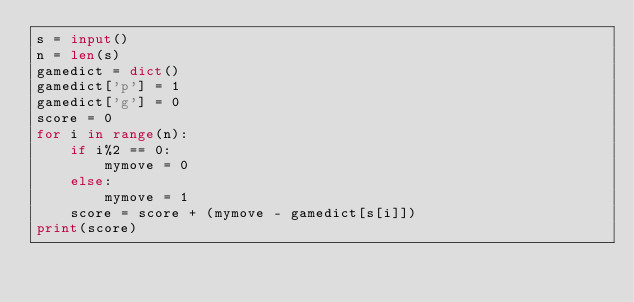Convert code to text. <code><loc_0><loc_0><loc_500><loc_500><_Python_>s = input()
n = len(s)
gamedict = dict()
gamedict['p'] = 1
gamedict['g'] = 0
score = 0
for i in range(n):
    if i%2 == 0:
        mymove = 0
    else:
        mymove = 1
    score = score + (mymove - gamedict[s[i]])
print(score)</code> 